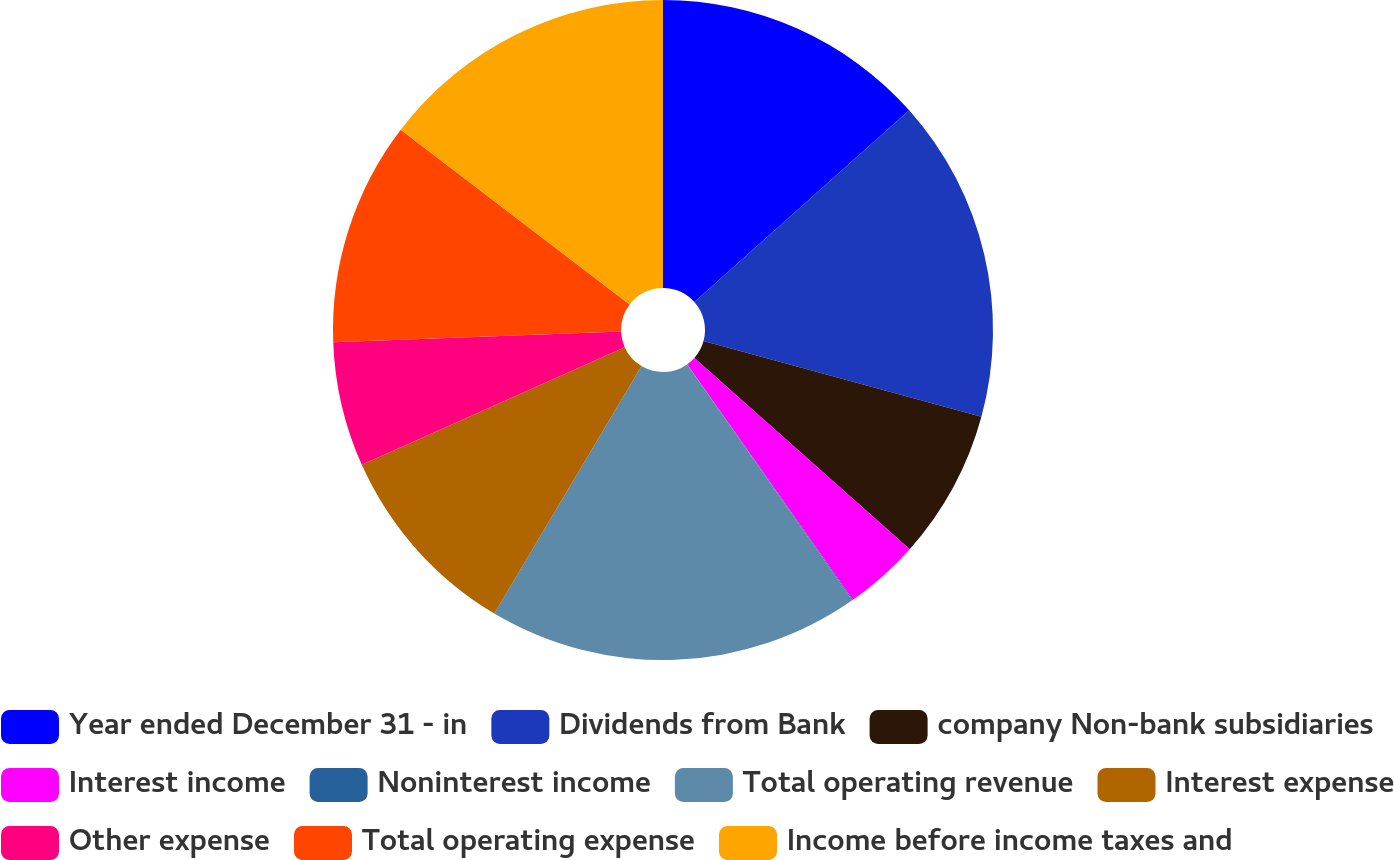Convert chart to OTSL. <chart><loc_0><loc_0><loc_500><loc_500><pie_chart><fcel>Year ended December 31 - in<fcel>Dividends from Bank<fcel>company Non-bank subsidiaries<fcel>Interest income<fcel>Noninterest income<fcel>Total operating revenue<fcel>Interest expense<fcel>Other expense<fcel>Total operating expense<fcel>Income before income taxes and<nl><fcel>13.4%<fcel>15.83%<fcel>7.33%<fcel>3.68%<fcel>0.04%<fcel>18.26%<fcel>9.76%<fcel>6.11%<fcel>10.97%<fcel>14.62%<nl></chart> 